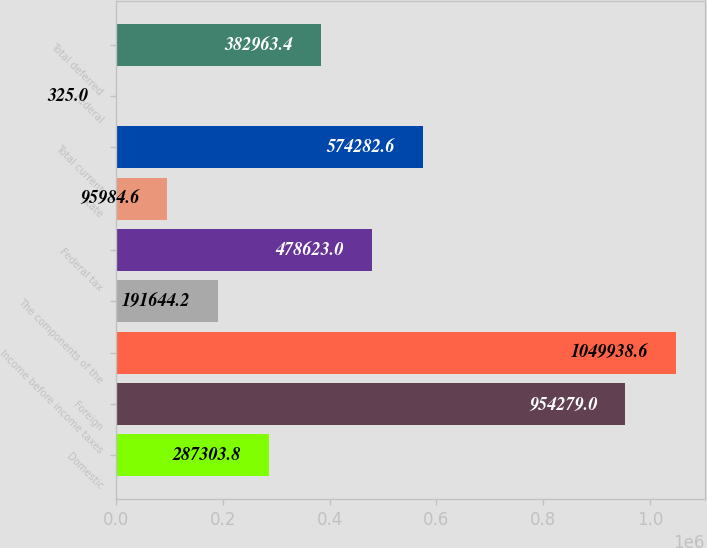Convert chart to OTSL. <chart><loc_0><loc_0><loc_500><loc_500><bar_chart><fcel>Domestic<fcel>Foreign<fcel>Income before income taxes<fcel>The components of the<fcel>Federal tax<fcel>State<fcel>Total current<fcel>Federal<fcel>Total deferred<nl><fcel>287304<fcel>954279<fcel>1.04994e+06<fcel>191644<fcel>478623<fcel>95984.6<fcel>574283<fcel>325<fcel>382963<nl></chart> 